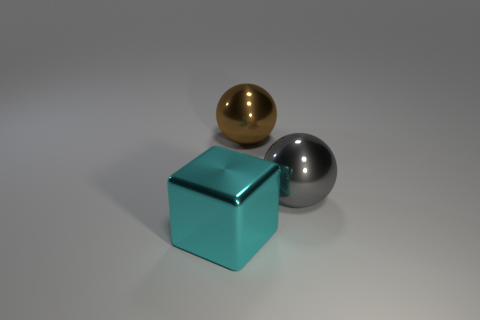Do the big metal thing behind the large gray metallic thing and the big object that is on the right side of the brown metal thing have the same shape?
Your answer should be compact. Yes. There is a large gray sphere; how many gray shiny things are behind it?
Your response must be concise. 0. What material is the large thing that is both on the left side of the gray metal sphere and on the right side of the large cyan object?
Offer a very short reply. Metal. How many green metal objects have the same size as the brown object?
Make the answer very short. 0. There is a object that is on the left side of the ball that is behind the gray sphere; what color is it?
Your answer should be compact. Cyan. Are there any small green rubber blocks?
Give a very brief answer. No. Is the brown thing the same shape as the big gray metallic object?
Give a very brief answer. Yes. How many large cyan metal things are left of the ball on the right side of the large brown metal sphere?
Offer a terse response. 1. What number of large metallic objects are both in front of the brown shiny object and right of the large cyan metal cube?
Offer a very short reply. 1. What number of objects are purple shiny objects or large things that are on the left side of the large brown thing?
Ensure brevity in your answer.  1. 